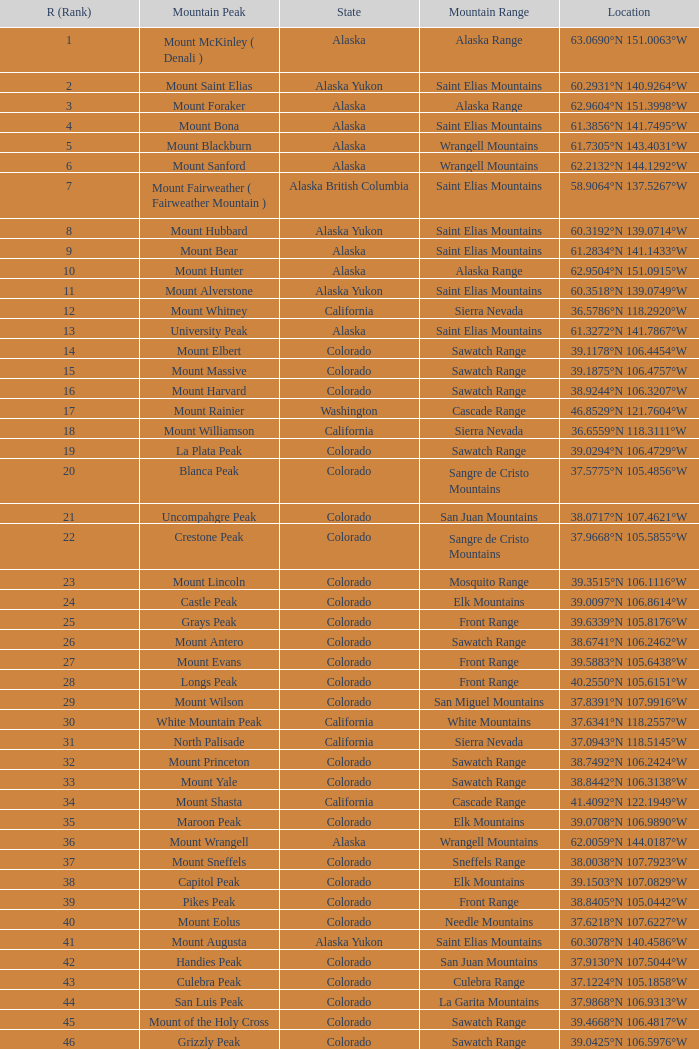What is the name of the mountain range in colorado that has a ranking greater than 90 and contains whetstone mountain as one of its peaks? West Elk Mountains. 